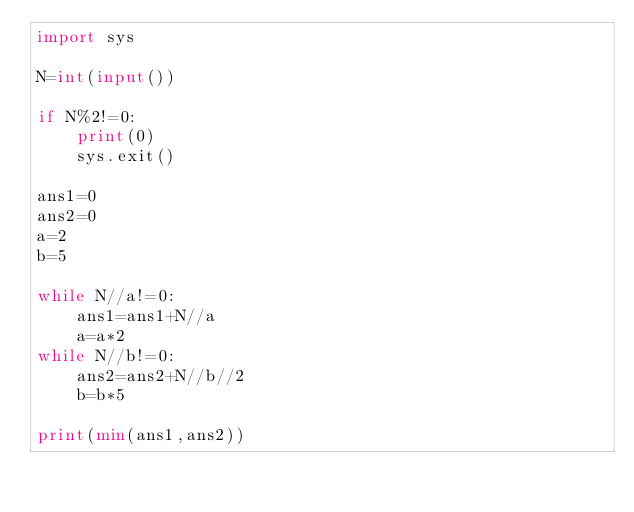<code> <loc_0><loc_0><loc_500><loc_500><_Python_>import sys

N=int(input())

if N%2!=0:
    print(0)
    sys.exit()

ans1=0
ans2=0
a=2
b=5

while N//a!=0:
    ans1=ans1+N//a
    a=a*2
while N//b!=0:
    ans2=ans2+N//b//2
    b=b*5

print(min(ans1,ans2))</code> 